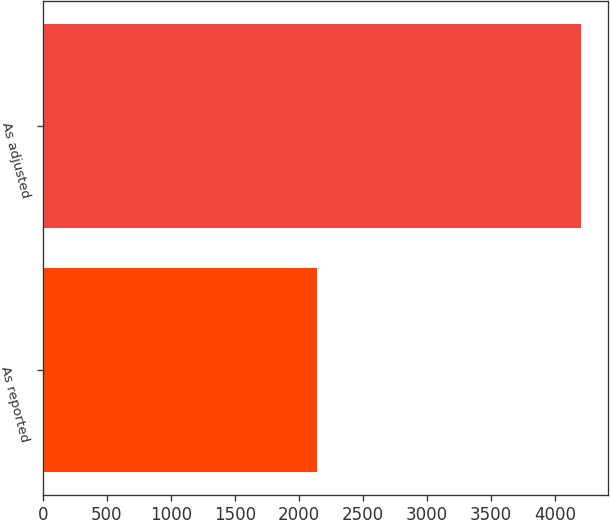Convert chart. <chart><loc_0><loc_0><loc_500><loc_500><bar_chart><fcel>As reported<fcel>As adjusted<nl><fcel>2144<fcel>4203<nl></chart> 